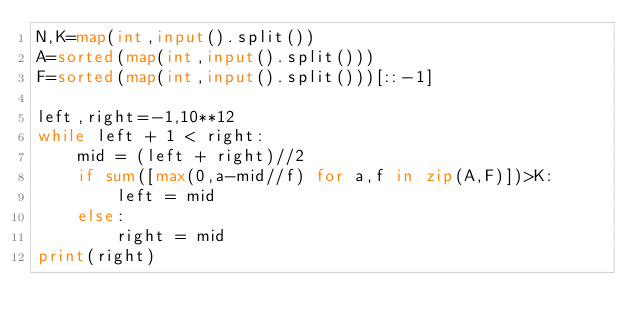<code> <loc_0><loc_0><loc_500><loc_500><_Python_>N,K=map(int,input().split())
A=sorted(map(int,input().split()))
F=sorted(map(int,input().split()))[::-1]

left,right=-1,10**12
while left + 1 < right:
    mid = (left + right)//2
    if sum([max(0,a-mid//f) for a,f in zip(A,F)])>K:
        left = mid
    else:
        right = mid
print(right)</code> 